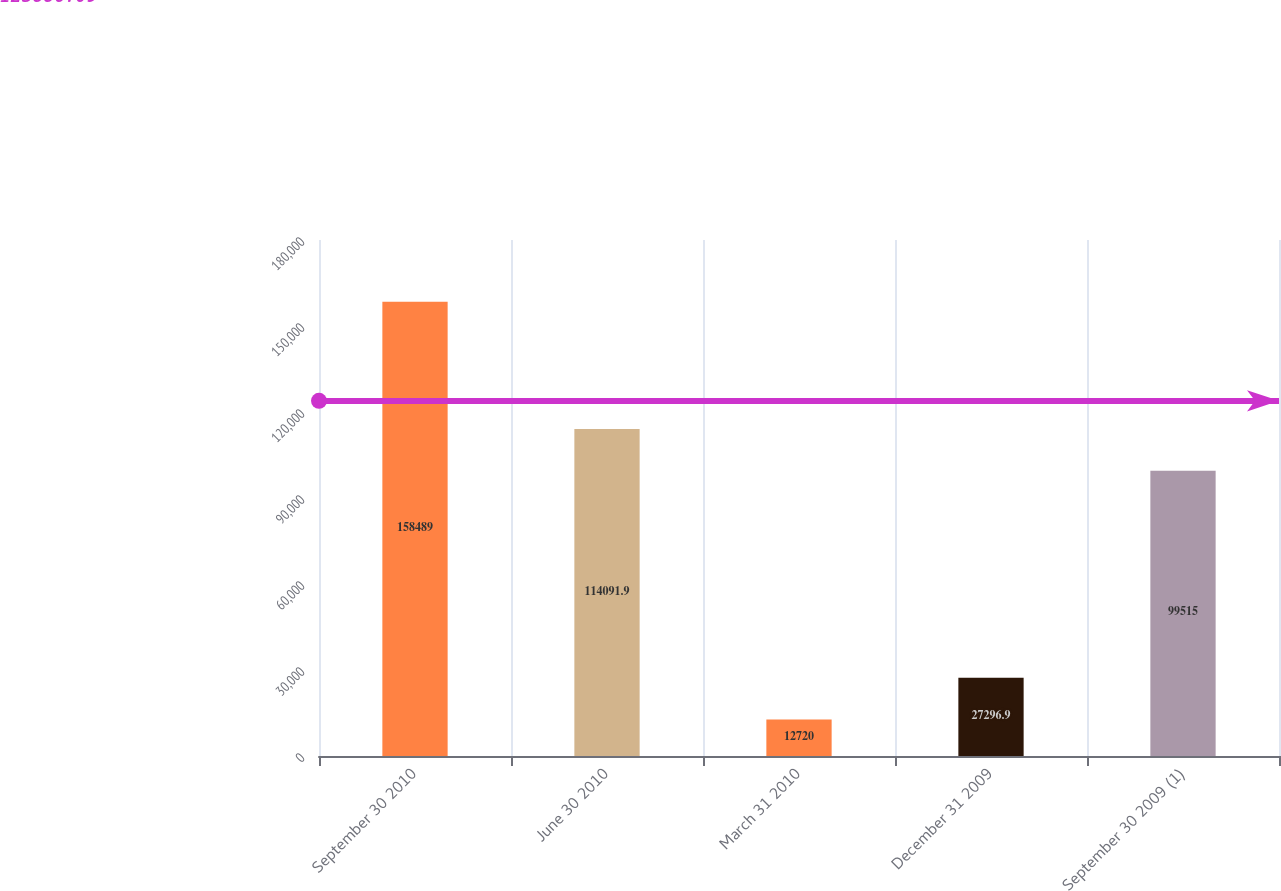<chart> <loc_0><loc_0><loc_500><loc_500><bar_chart><fcel>September 30 2010<fcel>June 30 2010<fcel>March 31 2010<fcel>December 31 2009<fcel>September 30 2009 (1)<nl><fcel>158489<fcel>114092<fcel>12720<fcel>27296.9<fcel>99515<nl></chart> 